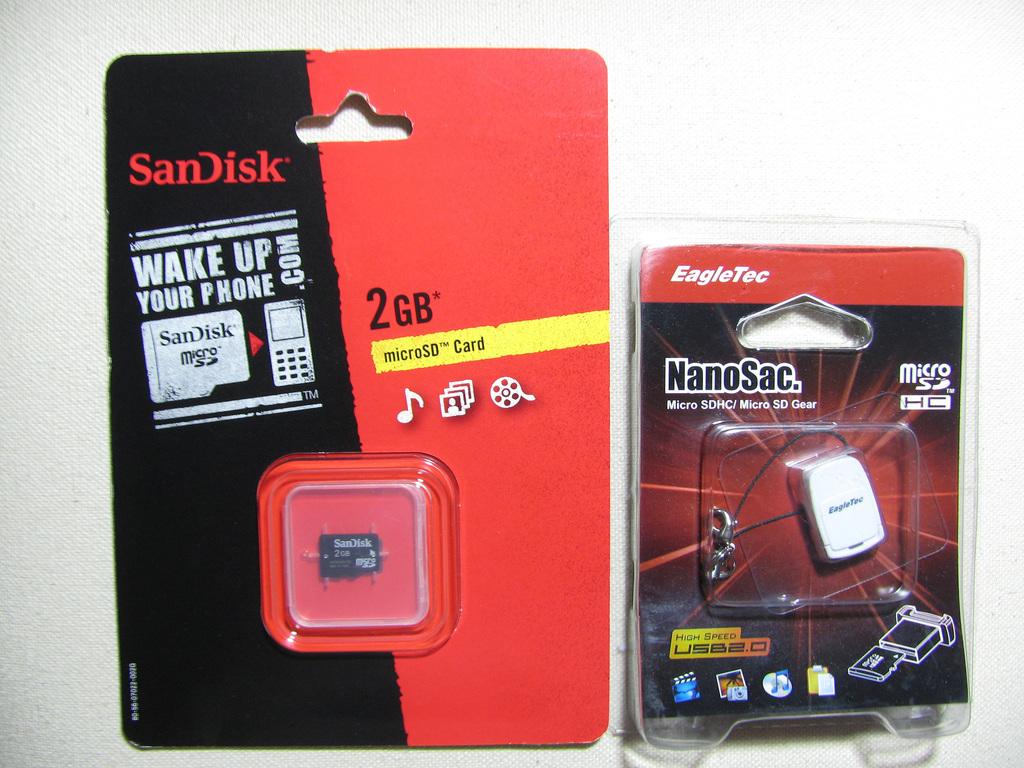What brand is this sd card?
Make the answer very short. Sandisk. How many gb is this microsd card?
Your answer should be very brief. 2. 